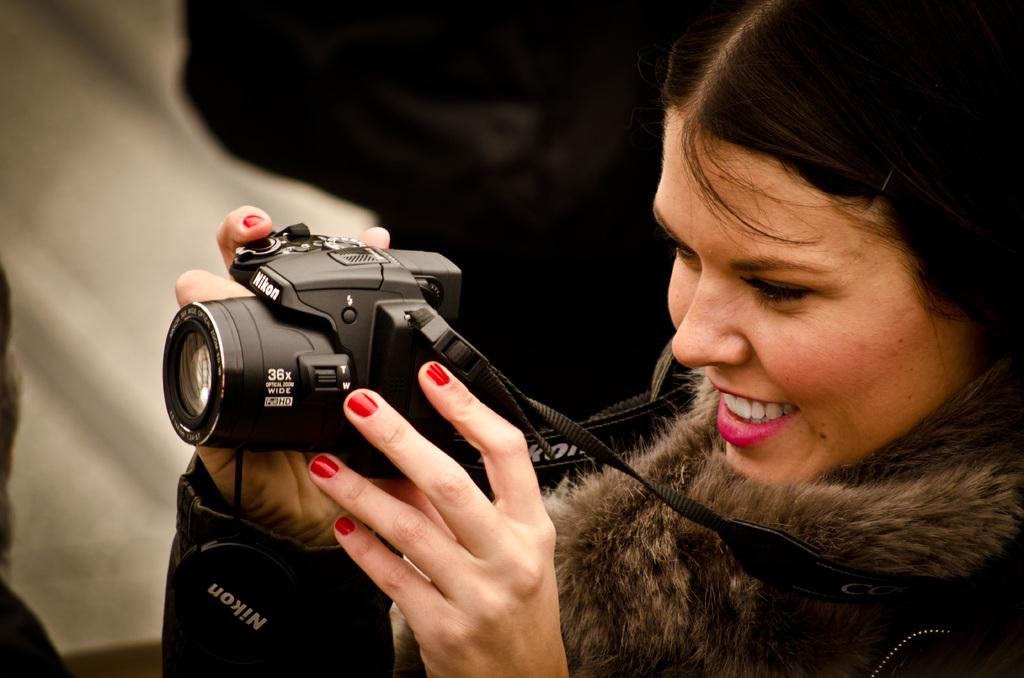Who is the main subject in the image? There is a woman in the image. What is the woman wearing? The woman is wearing a jacket. What is the woman holding in her hands? The woman is holding a camera in her hands. What is the color of the camera? The camera is black in color. How does the woman use magic to take pictures with the camera? There is no indication of magic being used in the image; the woman is simply holding a camera. 